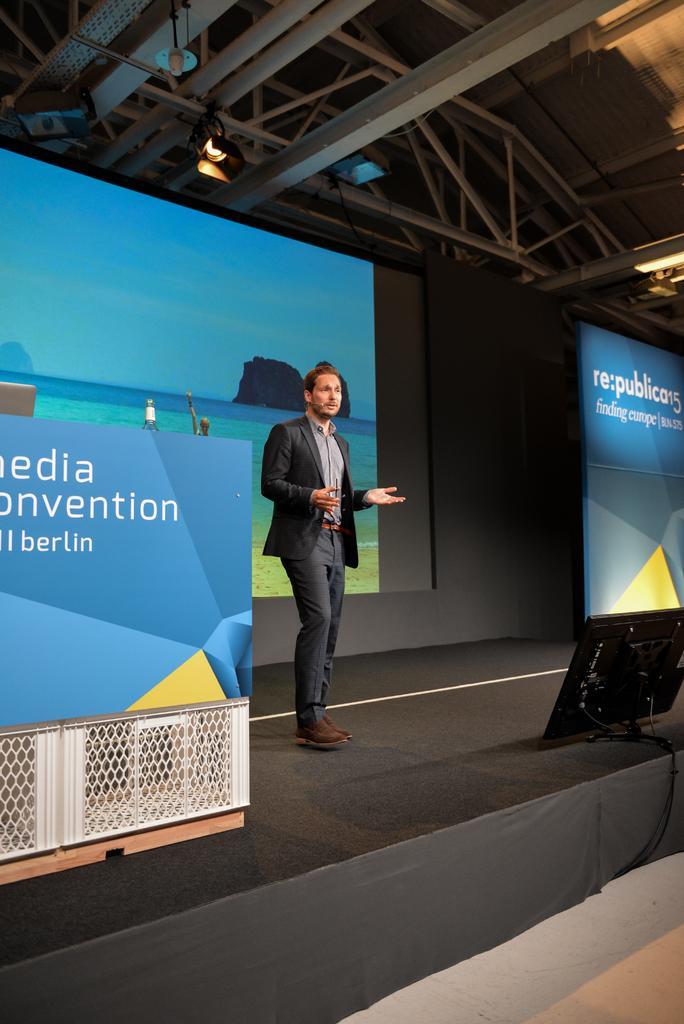Could you give a brief overview of what you see in this image? In this image there is a man standing on the stage. In front of him there is a screen. In the background there is a projector. At the top there is ceiling with the lights. On the left side there is a hoarding. 